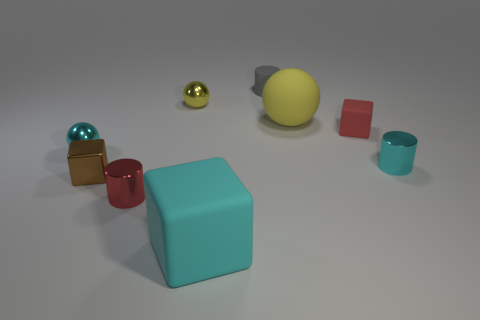Can you describe the lighting and shadows in the image? The image features soft, diffuse lighting, likely from an overhead source, creating gentle shadows beneath each object that help to define their shapes and the space they occupy. Does the lighting affect the colors of the objects? Yes, the diffuse nature of the light gives the colors a soft appearance and can slightly alter our perception of their intensity and saturation. 